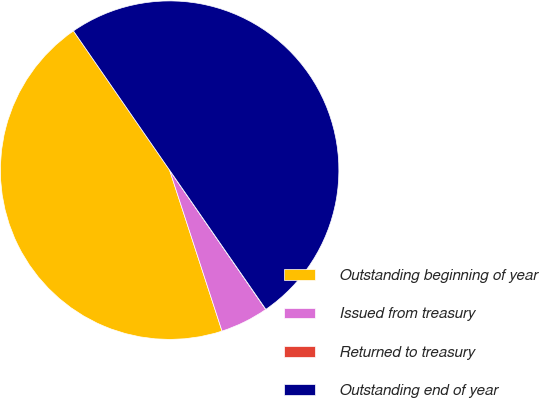Convert chart to OTSL. <chart><loc_0><loc_0><loc_500><loc_500><pie_chart><fcel>Outstanding beginning of year<fcel>Issued from treasury<fcel>Returned to treasury<fcel>Outstanding end of year<nl><fcel>45.39%<fcel>4.61%<fcel>0.01%<fcel>49.99%<nl></chart> 